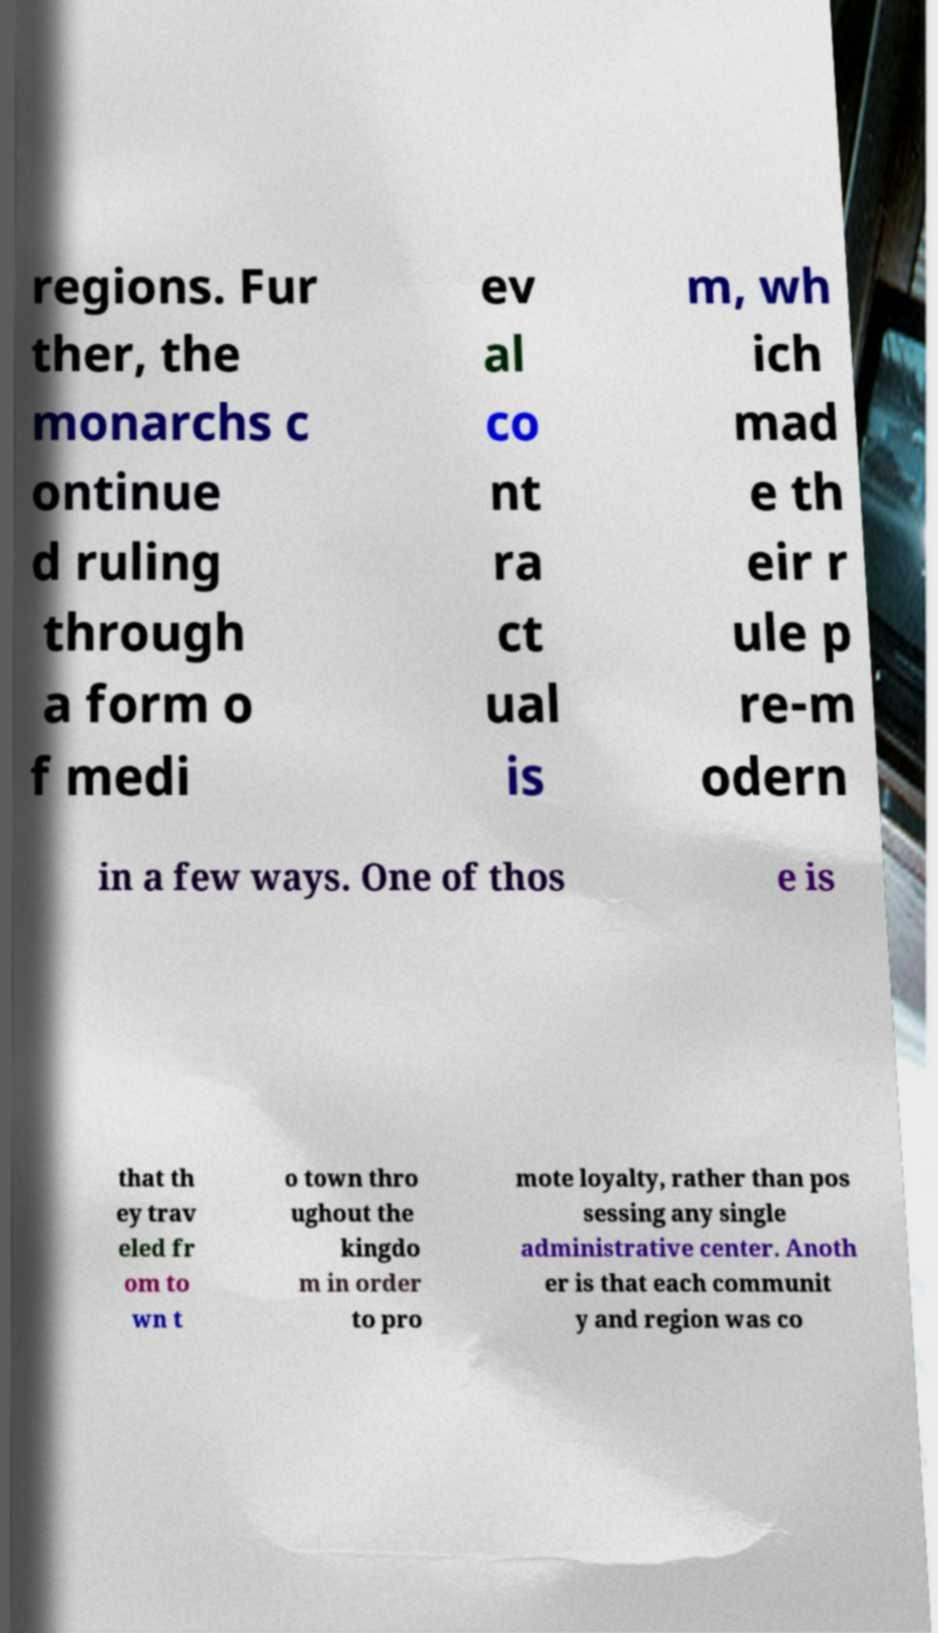There's text embedded in this image that I need extracted. Can you transcribe it verbatim? regions. Fur ther, the monarchs c ontinue d ruling through a form o f medi ev al co nt ra ct ual is m, wh ich mad e th eir r ule p re-m odern in a few ways. One of thos e is that th ey trav eled fr om to wn t o town thro ughout the kingdo m in order to pro mote loyalty, rather than pos sessing any single administrative center. Anoth er is that each communit y and region was co 